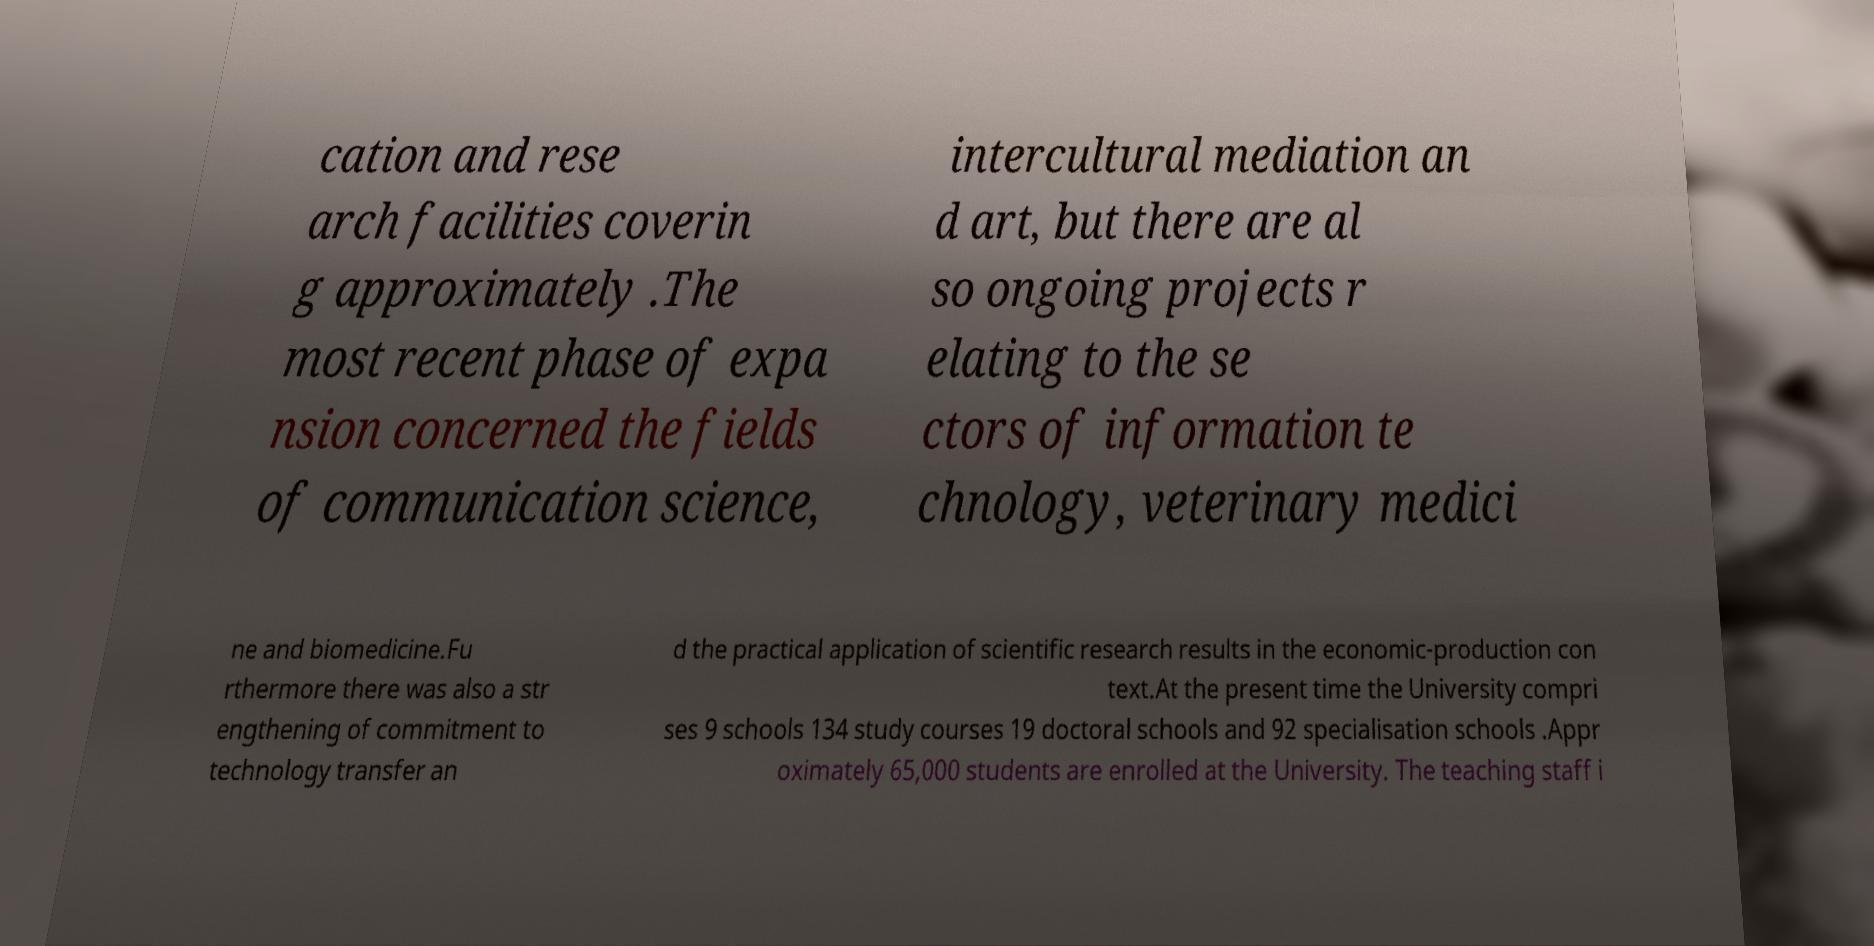Please identify and transcribe the text found in this image. cation and rese arch facilities coverin g approximately .The most recent phase of expa nsion concerned the fields of communication science, intercultural mediation an d art, but there are al so ongoing projects r elating to the se ctors of information te chnology, veterinary medici ne and biomedicine.Fu rthermore there was also a str engthening of commitment to technology transfer an d the practical application of scientific research results in the economic-production con text.At the present time the University compri ses 9 schools 134 study courses 19 doctoral schools and 92 specialisation schools .Appr oximately 65,000 students are enrolled at the University. The teaching staff i 